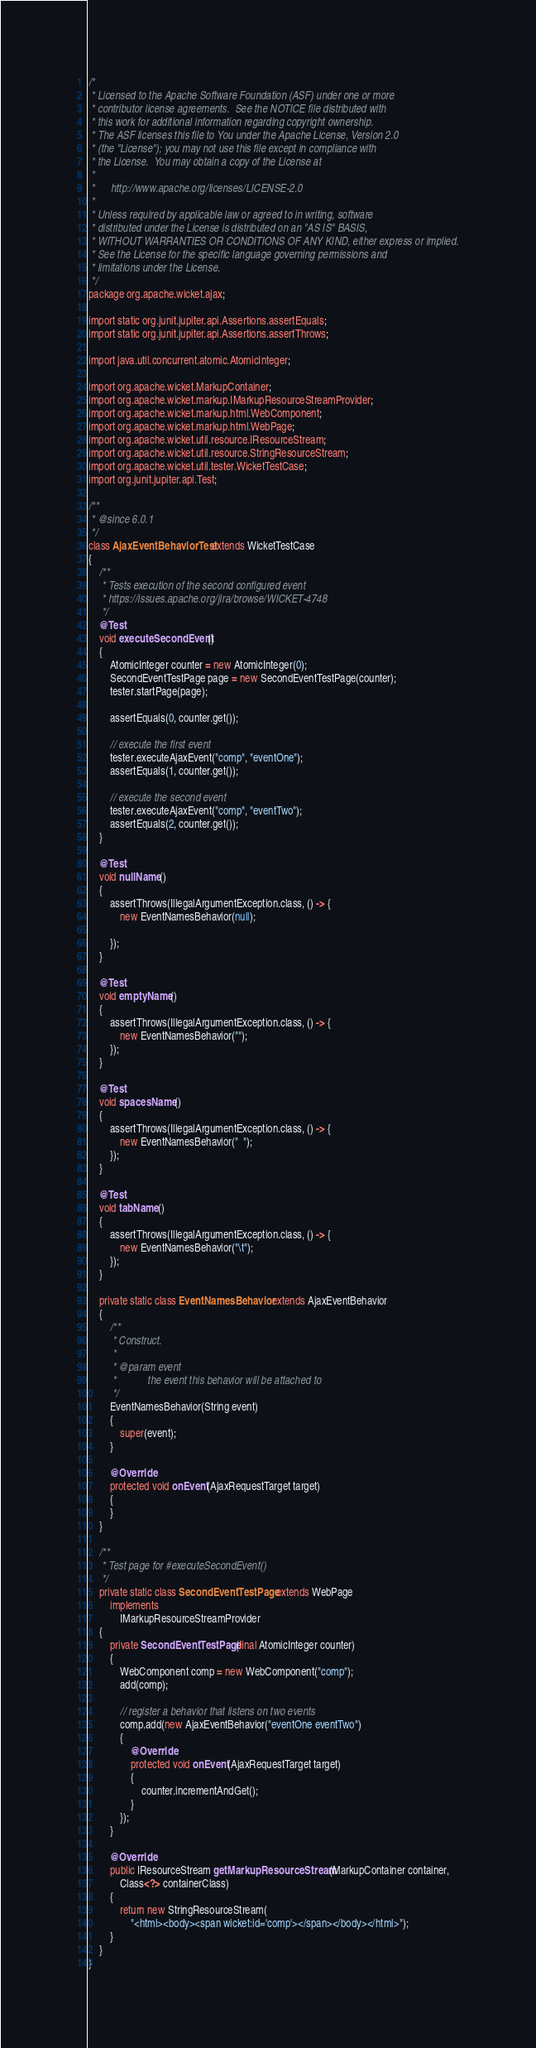<code> <loc_0><loc_0><loc_500><loc_500><_Java_>/*
 * Licensed to the Apache Software Foundation (ASF) under one or more
 * contributor license agreements.  See the NOTICE file distributed with
 * this work for additional information regarding copyright ownership.
 * The ASF licenses this file to You under the Apache License, Version 2.0
 * (the "License"); you may not use this file except in compliance with
 * the License.  You may obtain a copy of the License at
 *
 *      http://www.apache.org/licenses/LICENSE-2.0
 *
 * Unless required by applicable law or agreed to in writing, software
 * distributed under the License is distributed on an "AS IS" BASIS,
 * WITHOUT WARRANTIES OR CONDITIONS OF ANY KIND, either express or implied.
 * See the License for the specific language governing permissions and
 * limitations under the License.
 */
package org.apache.wicket.ajax;

import static org.junit.jupiter.api.Assertions.assertEquals;
import static org.junit.jupiter.api.Assertions.assertThrows;

import java.util.concurrent.atomic.AtomicInteger;

import org.apache.wicket.MarkupContainer;
import org.apache.wicket.markup.IMarkupResourceStreamProvider;
import org.apache.wicket.markup.html.WebComponent;
import org.apache.wicket.markup.html.WebPage;
import org.apache.wicket.util.resource.IResourceStream;
import org.apache.wicket.util.resource.StringResourceStream;
import org.apache.wicket.util.tester.WicketTestCase;
import org.junit.jupiter.api.Test;

/**
 * @since 6.0.1
 */
class AjaxEventBehaviorTest extends WicketTestCase
{
	/**
	 * Tests execution of the second configured event
	 * https://issues.apache.org/jira/browse/WICKET-4748
	 */
	@Test
	void executeSecondEvent()
	{
		AtomicInteger counter = new AtomicInteger(0);
		SecondEventTestPage page = new SecondEventTestPage(counter);
		tester.startPage(page);

		assertEquals(0, counter.get());

		// execute the first event
		tester.executeAjaxEvent("comp", "eventOne");
		assertEquals(1, counter.get());

		// execute the second event
		tester.executeAjaxEvent("comp", "eventTwo");
		assertEquals(2, counter.get());
	}

	@Test
	void nullName()
	{
		assertThrows(IllegalArgumentException.class, () -> {
			new EventNamesBehavior(null);

		});
	}

	@Test
	void emptyName()
	{
		assertThrows(IllegalArgumentException.class, () -> {
			new EventNamesBehavior("");
		});
	}

	@Test
	void spacesName()
	{
		assertThrows(IllegalArgumentException.class, () -> {
			new EventNamesBehavior("  ");
		});
	}

	@Test
	void tabName()
	{
		assertThrows(IllegalArgumentException.class, () -> {
			new EventNamesBehavior("\t");
		});
	}

	private static class EventNamesBehavior extends AjaxEventBehavior
	{
		/**
		 * Construct.
		 *
		 * @param event
		 *            the event this behavior will be attached to
		 */
		EventNamesBehavior(String event)
		{
			super(event);
		}

		@Override
		protected void onEvent(AjaxRequestTarget target)
		{
		}
	}

	/**
	 * Test page for #executeSecondEvent()
	 */
	private static class SecondEventTestPage extends WebPage
		implements
			IMarkupResourceStreamProvider
	{
		private SecondEventTestPage(final AtomicInteger counter)
		{
			WebComponent comp = new WebComponent("comp");
			add(comp);

			// register a behavior that listens on two events
			comp.add(new AjaxEventBehavior("eventOne eventTwo")
			{
				@Override
				protected void onEvent(AjaxRequestTarget target)
				{
					counter.incrementAndGet();
				}
			});
		}

		@Override
		public IResourceStream getMarkupResourceStream(MarkupContainer container,
			Class<?> containerClass)
		{
			return new StringResourceStream(
				"<html><body><span wicket:id='comp'></span></body></html>");
		}
	}
}
</code> 